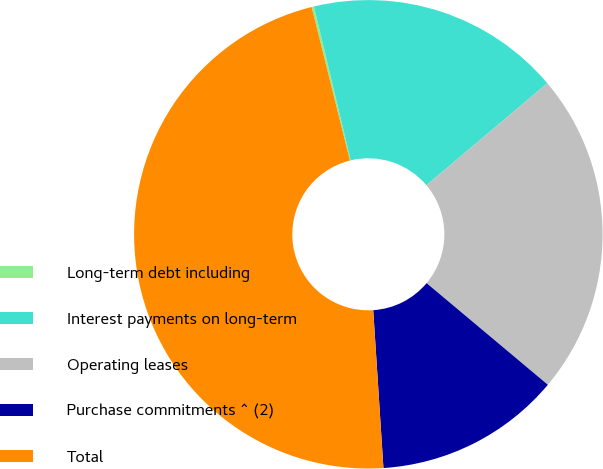Convert chart to OTSL. <chart><loc_0><loc_0><loc_500><loc_500><pie_chart><fcel>Long-term debt including<fcel>Interest payments on long-term<fcel>Operating leases<fcel>Purchase commitments ^ (2)<fcel>Total<nl><fcel>0.16%<fcel>17.57%<fcel>22.26%<fcel>12.87%<fcel>47.14%<nl></chart> 